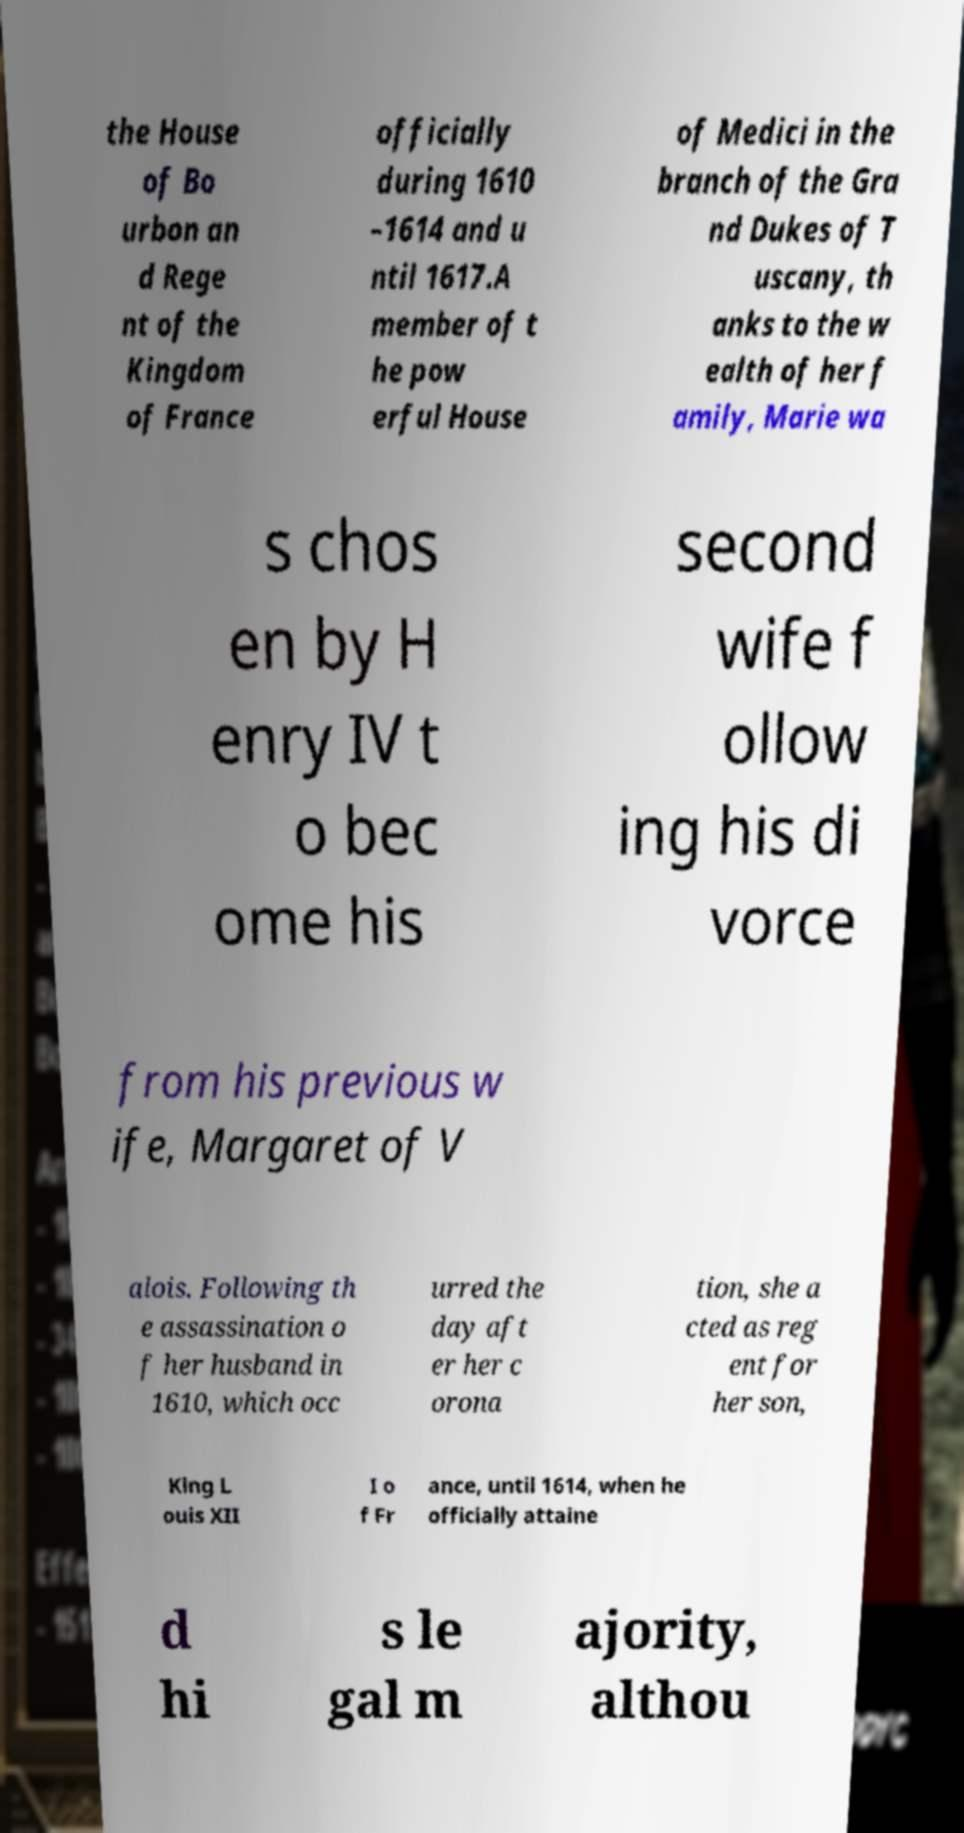What messages or text are displayed in this image? I need them in a readable, typed format. the House of Bo urbon an d Rege nt of the Kingdom of France officially during 1610 –1614 and u ntil 1617.A member of t he pow erful House of Medici in the branch of the Gra nd Dukes of T uscany, th anks to the w ealth of her f amily, Marie wa s chos en by H enry IV t o bec ome his second wife f ollow ing his di vorce from his previous w ife, Margaret of V alois. Following th e assassination o f her husband in 1610, which occ urred the day aft er her c orona tion, she a cted as reg ent for her son, King L ouis XII I o f Fr ance, until 1614, when he officially attaine d hi s le gal m ajority, althou 